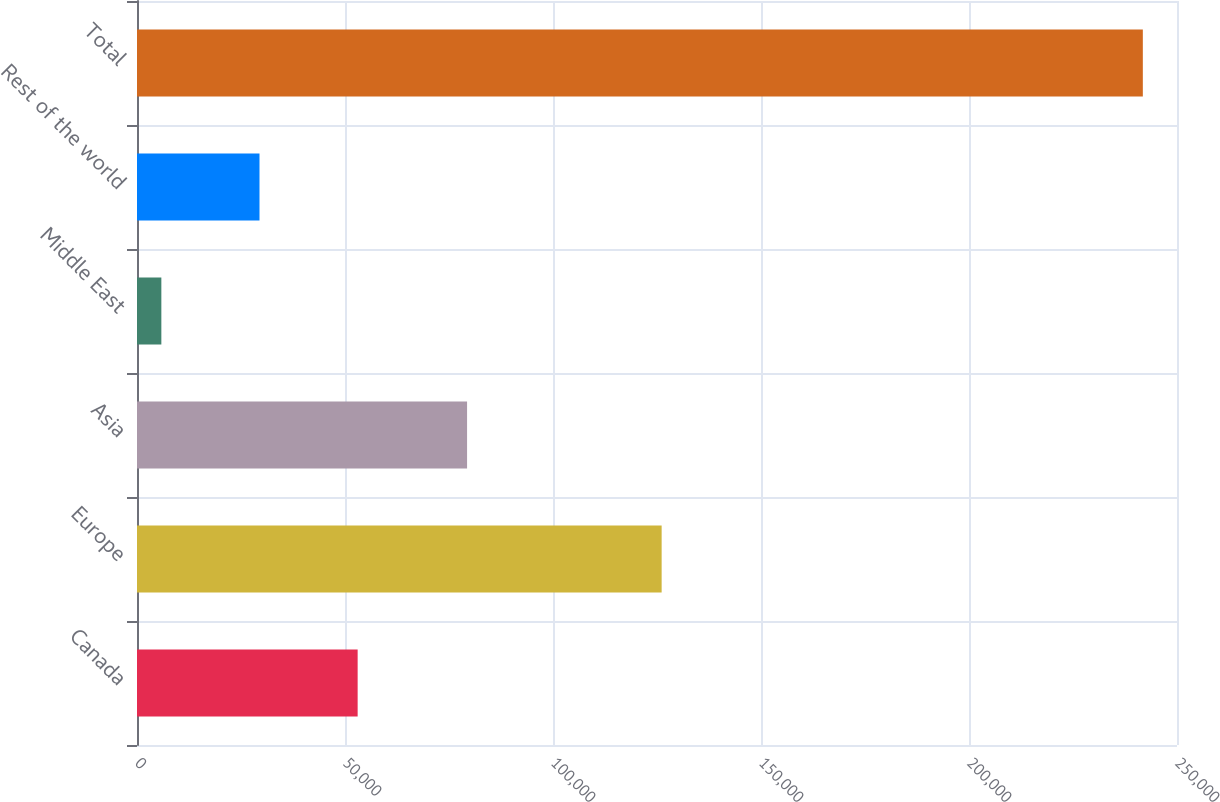Convert chart. <chart><loc_0><loc_0><loc_500><loc_500><bar_chart><fcel>Canada<fcel>Europe<fcel>Asia<fcel>Middle East<fcel>Rest of the world<fcel>Total<nl><fcel>53039.8<fcel>126116<fcel>79343<fcel>5853<fcel>29446.4<fcel>241787<nl></chart> 